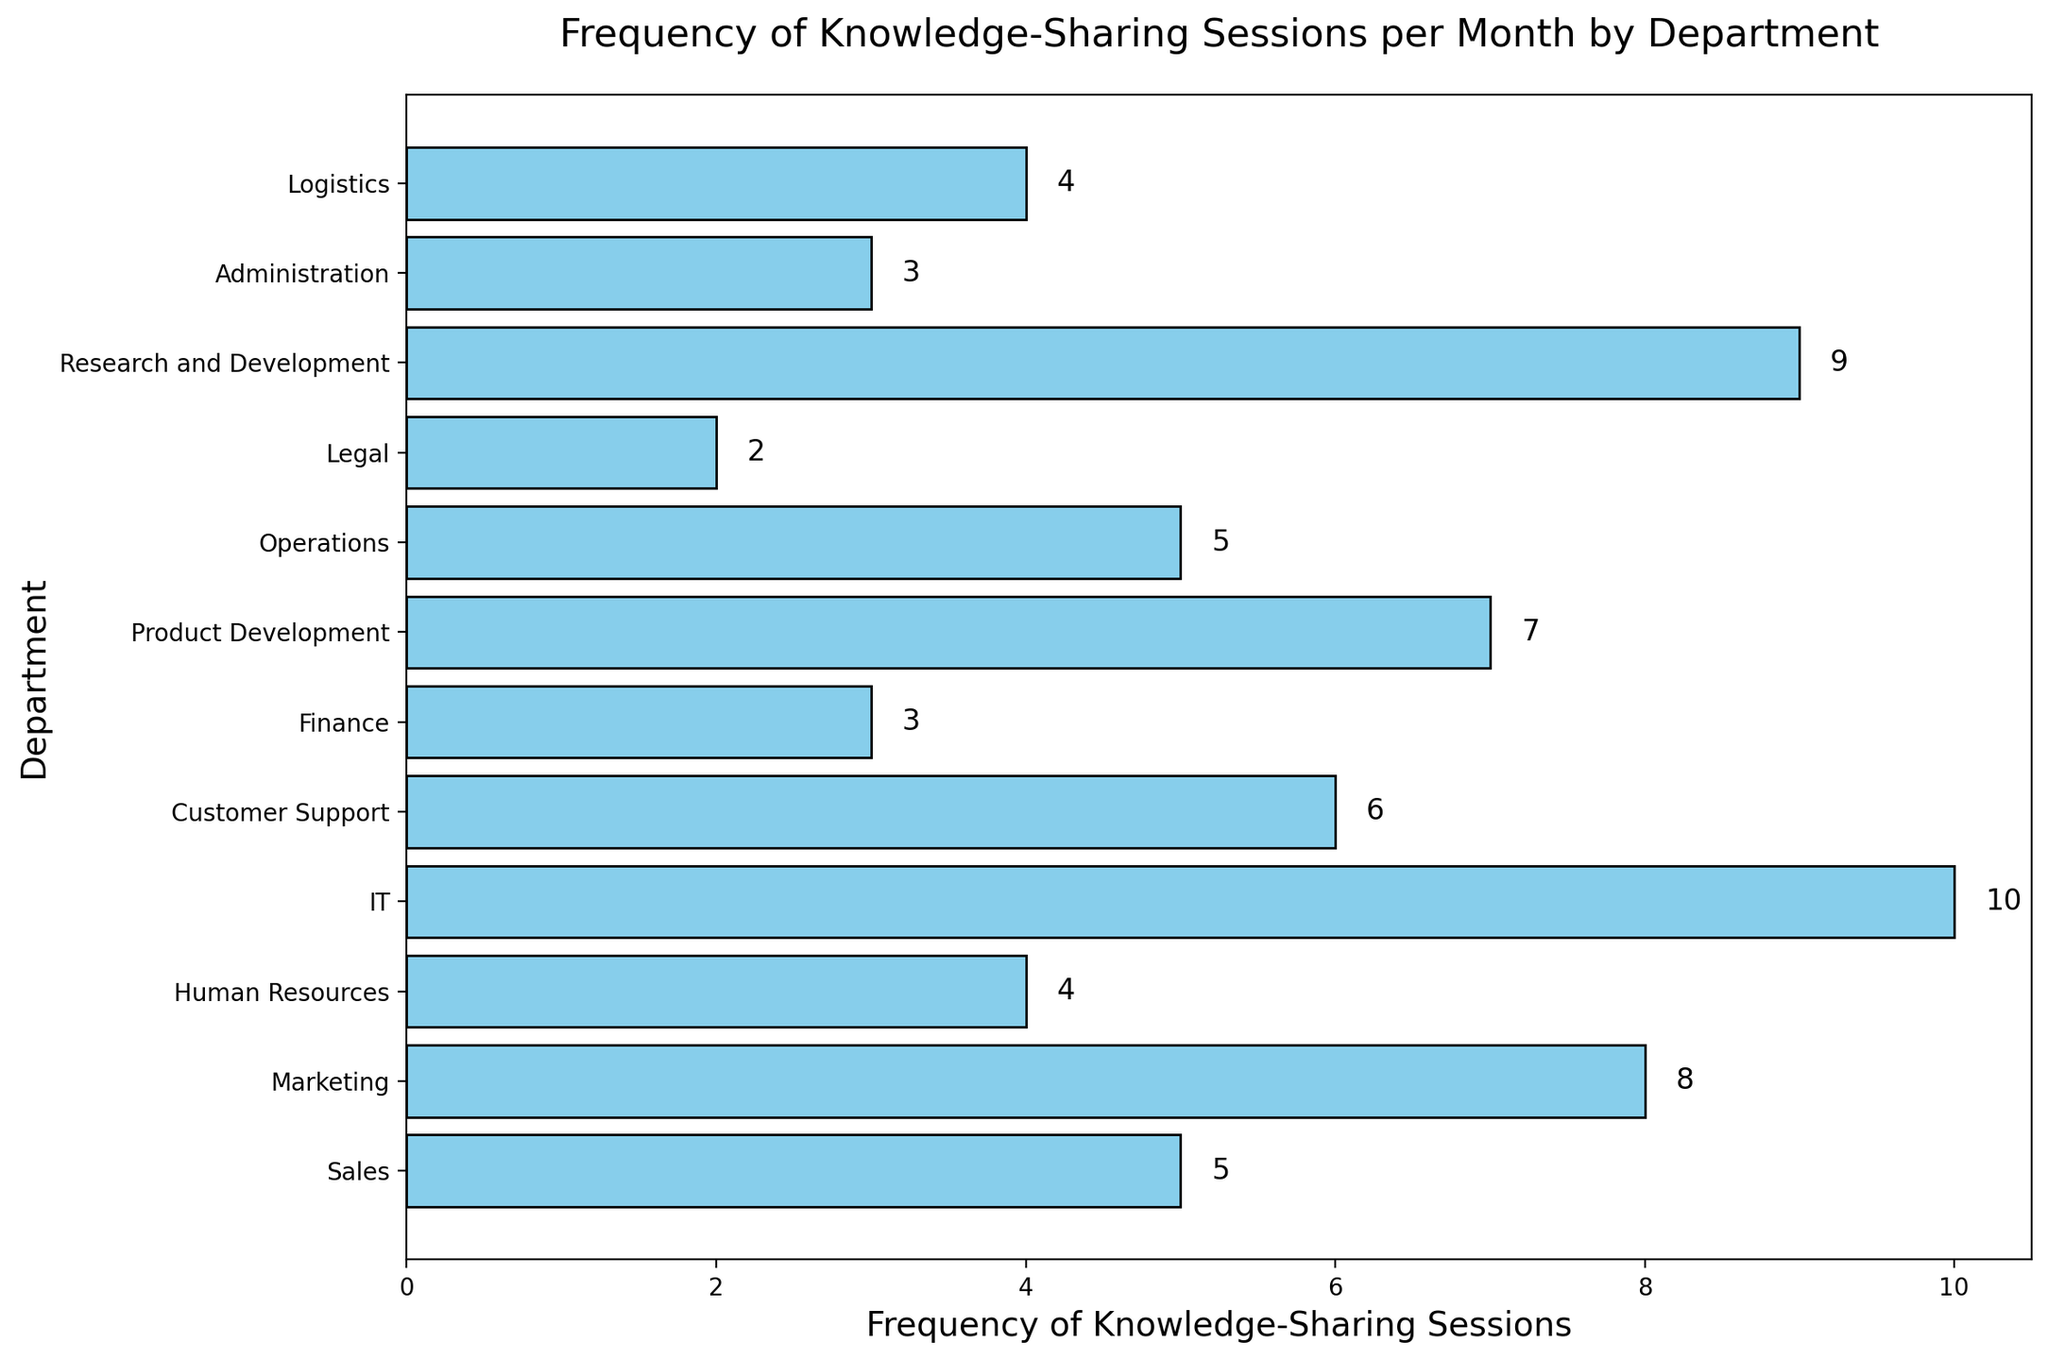Which department has the highest frequency of knowledge-sharing sessions? The department with the tallest bar on the graph represents the highest frequency. In this case, IT has the tallest bar with a frequency of 10.
Answer: IT Which department has the lowest frequency of knowledge-sharing sessions? The department with the shortest bar on the graph represents the lowest frequency. In this case, Legal has the shortest bar with a frequency of 2.
Answer: Legal What is the average frequency of knowledge-sharing sessions for the Sales, Marketing, and IT departments? First, add the frequencies: Sales (5) + Marketing (8) + IT (10) = 23. Then, divide by the number of departments (3). So, the average is 23 / 3 = 7.67.
Answer: 7.67 Are the number of sessions in the Marketing department greater than the Customer Support and Finance departments combined? First, sum the frequencies of the Customer Support and Finance departments: Customer Support (6) + Finance (3) = 9. The Marketing department has a frequency of 8, which is less than 9.
Answer: No Which department has a frequency exactly in the middle of the range? The frequencies in ascending order are: 2, 3, 3, 4, 4, 5, 5, 6, 7, 8, 9, 10. The middle value (median) is between the 6th and 7th values, which are both 5 (Sales and Operations).
Answer: Sales and Operations Which bar is colored differently than the others? All bars are colored similarly in sky blue. None are colored differently.
Answer: None What is the total frequency of knowledge-sharing sessions for all departments combined? Sum all the frequencies given: 5 (Sales) + 8 (Marketing) + 4 (Human Resources) + 10 (IT) + 6 (Customer Support) + 3 (Finance) + 7 (Product Development) + 5 (Operations) + 2 (Legal) + 9 (Research and Development) + 3 (Administration) + 4 (Logistics) = 66.
Answer: 66 Is the frequency of sessions in IT more than twice the frequency in the Finance department? IT has a frequency of 10, and Finance has a frequency of 3. Twice the frequency of Finance is 3 * 2 = 6. Since 10 is greater than 6, IT has more than twice the frequency.
Answer: Yes 